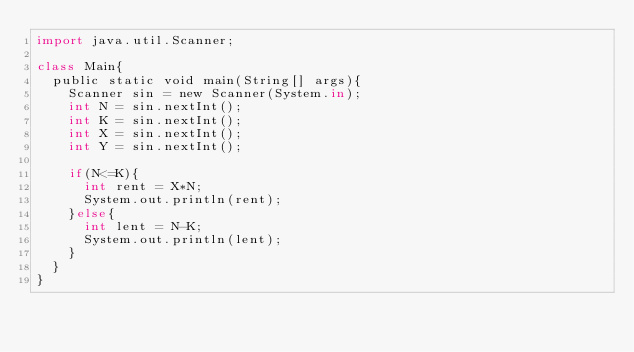Convert code to text. <code><loc_0><loc_0><loc_500><loc_500><_Python_>import java.util.Scanner;

class Main{
  public static void main(String[] args){
    Scanner sin = new Scanner(System.in);
    int N = sin.nextInt();
    int K = sin.nextInt();
    int X = sin.nextInt();
    int Y = sin.nextInt();
    
    if(N<=K){
      int rent = X*N;
      System.out.println(rent);
    }else{
      int lent = N-K;
      System.out.println(lent);
    }
  }  
}</code> 